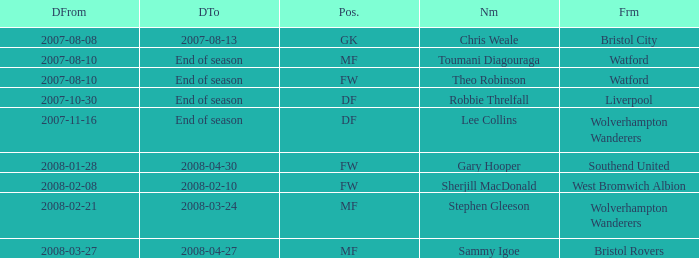What date did Toumani Diagouraga, who played position MF, start? 2007-08-10. 